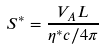<formula> <loc_0><loc_0><loc_500><loc_500>S ^ { * } = \frac { V _ { A } L } { \eta ^ { * } c / 4 \pi }</formula> 